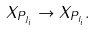<formula> <loc_0><loc_0><loc_500><loc_500>X _ { P _ { J _ { i } } } \rightarrow X _ { P _ { I _ { i } } } .</formula> 